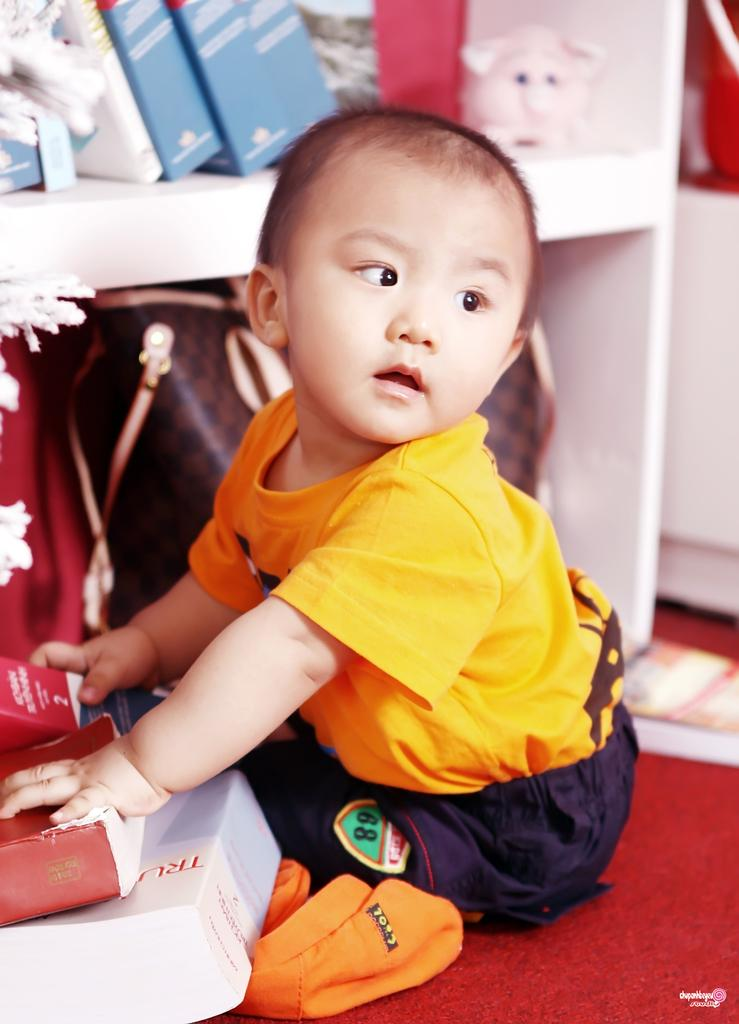What is the boy in the image doing? The boy is sitting in the front of the image and holding books. What might the boy be doing with the books? The boy might be reading or studying with the books. What can be seen in the background of the image? There is a shelf in the background of the image. What items are on the shelf? There are books and purses on the shelf. Is the boy crying while holding the books in the image? There is no indication in the image that the boy is crying; he is simply holding books. 